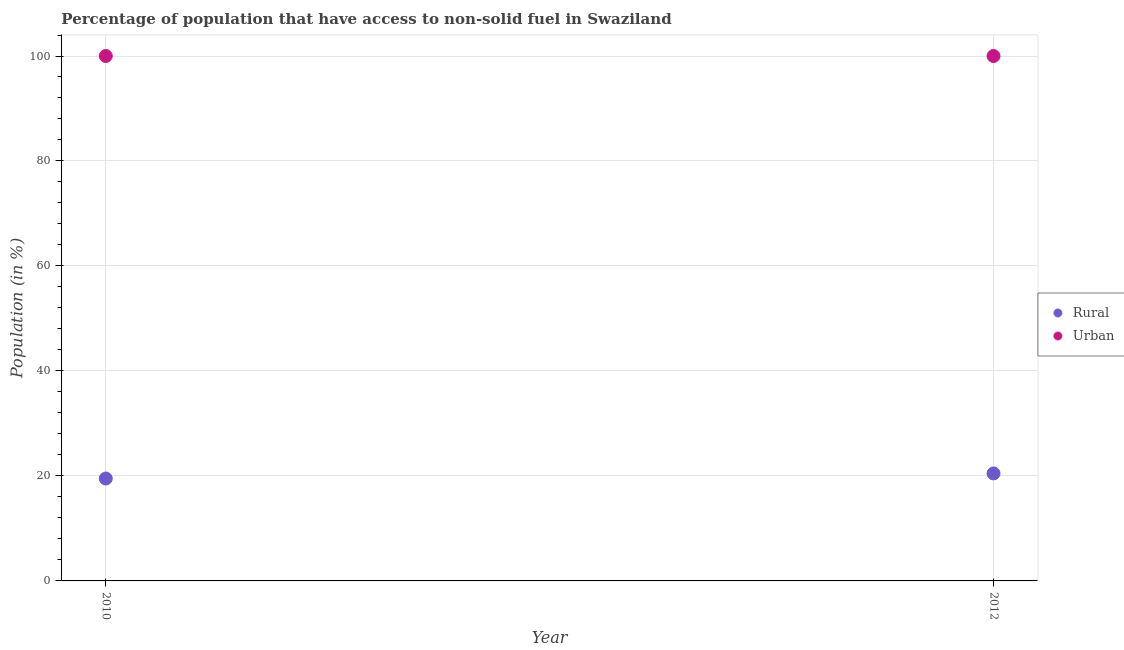How many different coloured dotlines are there?
Make the answer very short. 2. Is the number of dotlines equal to the number of legend labels?
Your answer should be compact. Yes. What is the rural population in 2010?
Provide a short and direct response. 19.51. Across all years, what is the maximum rural population?
Your answer should be compact. 20.48. Across all years, what is the minimum urban population?
Make the answer very short. 100. In which year was the urban population minimum?
Keep it short and to the point. 2010. What is the total urban population in the graph?
Your answer should be compact. 200. What is the difference between the rural population in 2010 and that in 2012?
Keep it short and to the point. -0.97. What is the difference between the rural population in 2010 and the urban population in 2012?
Ensure brevity in your answer.  -80.49. In the year 2012, what is the difference between the urban population and rural population?
Make the answer very short. 79.52. In how many years, is the rural population greater than 80 %?
Your answer should be very brief. 0. What is the ratio of the rural population in 2010 to that in 2012?
Ensure brevity in your answer.  0.95. Is the urban population in 2010 less than that in 2012?
Your answer should be compact. No. In how many years, is the rural population greater than the average rural population taken over all years?
Your answer should be compact. 1. Does the rural population monotonically increase over the years?
Keep it short and to the point. Yes. Is the urban population strictly less than the rural population over the years?
Your answer should be very brief. No. How many years are there in the graph?
Provide a short and direct response. 2. How many legend labels are there?
Your answer should be very brief. 2. What is the title of the graph?
Offer a terse response. Percentage of population that have access to non-solid fuel in Swaziland. Does "Food and tobacco" appear as one of the legend labels in the graph?
Your answer should be compact. No. What is the Population (in %) of Rural in 2010?
Make the answer very short. 19.51. What is the Population (in %) of Urban in 2010?
Give a very brief answer. 100. What is the Population (in %) of Rural in 2012?
Offer a terse response. 20.48. What is the Population (in %) in Urban in 2012?
Your response must be concise. 100. Across all years, what is the maximum Population (in %) of Rural?
Your answer should be compact. 20.48. Across all years, what is the minimum Population (in %) of Rural?
Provide a succinct answer. 19.51. Across all years, what is the minimum Population (in %) in Urban?
Provide a short and direct response. 100. What is the total Population (in %) in Rural in the graph?
Provide a succinct answer. 39.99. What is the total Population (in %) of Urban in the graph?
Your answer should be compact. 200. What is the difference between the Population (in %) in Rural in 2010 and that in 2012?
Provide a succinct answer. -0.97. What is the difference between the Population (in %) of Rural in 2010 and the Population (in %) of Urban in 2012?
Offer a very short reply. -80.49. What is the average Population (in %) of Rural per year?
Ensure brevity in your answer.  19.99. In the year 2010, what is the difference between the Population (in %) of Rural and Population (in %) of Urban?
Offer a terse response. -80.49. In the year 2012, what is the difference between the Population (in %) of Rural and Population (in %) of Urban?
Offer a terse response. -79.52. What is the ratio of the Population (in %) in Rural in 2010 to that in 2012?
Give a very brief answer. 0.95. What is the difference between the highest and the second highest Population (in %) in Rural?
Provide a succinct answer. 0.97. What is the difference between the highest and the lowest Population (in %) in Rural?
Offer a terse response. 0.97. 